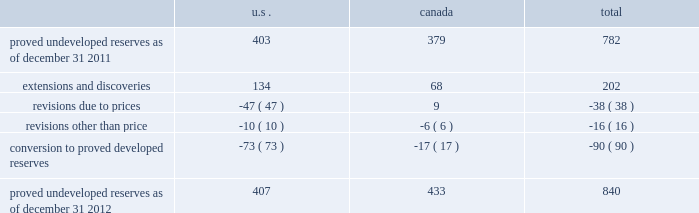Devon energy corporation and subsidiaries notes to consolidated financial statements 2013 ( continued ) proved undeveloped reserves the table presents the changes in devon 2019s total proved undeveloped reserves during 2012 ( in mmboe ) . .
At december 31 , 2012 , devon had 840 mmboe of proved undeveloped reserves .
This represents a 7 percent increase as compared to 2011 and represents 28 percent of its total proved reserves .
Drilling and development activities increased devon 2019s proved undeveloped reserves 203 mmboe and resulted in the conversion of 90 mmboe , or 12 percent , of the 2011 proved undeveloped reserves to proved developed reserves .
Costs incurred related to the development and conversion of devon 2019s proved undeveloped reserves were $ 1.3 billion for 2012 .
Additionally , revisions other than price decreased devon 2019s proved undeveloped reserves 16 mmboe primarily due to its evaluation of certain u.s .
Onshore dry-gas areas , which it does not expect to develop in the next five years .
The largest revisions relate to the dry-gas areas at carthage in east texas and the barnett shale in north texas .
A significant amount of devon 2019s proved undeveloped reserves at the end of 2012 largely related to its jackfish operations .
At december 31 , 2012 and 2011 , devon 2019s jackfish proved undeveloped reserves were 429 mmboe and 367 mmboe , respectively .
Development schedules for the jackfish reserves are primarily controlled by the need to keep the processing plants at their 35000 barrel daily facility capacity .
Processing plant capacity is controlled by factors such as total steam processing capacity , steam-oil ratios and air quality discharge permits .
As a result , these reserves are classified as proved undeveloped for more than five years .
Currently , the development schedule for these reserves extends though the year 2031 .
Price revisions 2012 - reserves decreased 171 mmboe primarily due to lower gas prices .
Of this decrease , 100 mmboe related to the barnett shale and 25 mmboe related to the rocky mountain area .
2011 - reserves decreased 21 mmboe due to lower gas prices and higher oil prices .
The higher oil prices increased devon 2019s canadian royalty burden , which reduced devon 2019s oil reserves .
2010 - reserves increased 72 mmboe due to higher gas prices , partially offset by the effect of higher oil prices .
The higher oil prices increased devon 2019s canadian royalty burden , which reduced devon 2019s oil reserves .
Of the 72 mmboe price revisions , 43 mmboe related to the barnett shale and 22 mmboe related to the rocky mountain area .
Revisions other than price total revisions other than price for 2012 and 2011 primarily related to devon 2019s evaluation of certain dry gas regions noted in the proved undeveloped reserves discussion above .
Total revisions other than price for 2010 primarily related to devon 2019s drilling and development in the barnett shale. .
What is the approximate total amount of proved reserves? 
Computations: ((100 / 28) * 840)
Answer: 3000.0. 